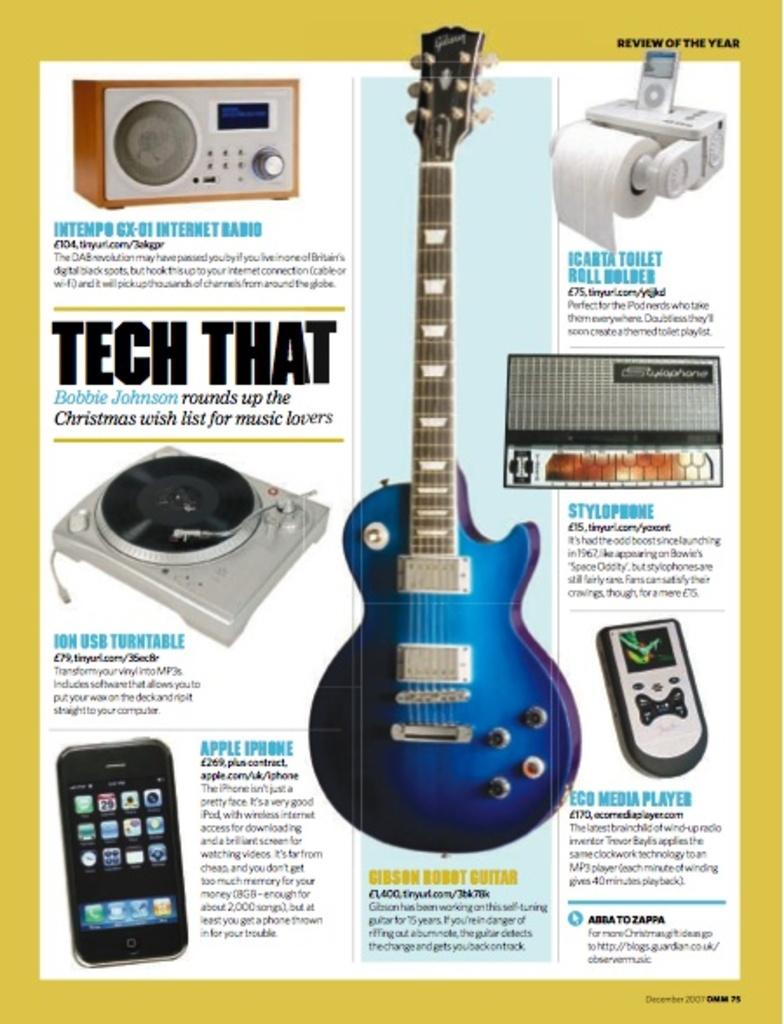What is written below tech that?
Give a very brief answer. Bobbie johnson rounds up the. What kind of radio is seen here?
Your answer should be very brief. Internet radio. 